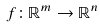Convert formula to latex. <formula><loc_0><loc_0><loc_500><loc_500>f \colon \mathbb { R } ^ { m } \to \mathbb { R } ^ { n }</formula> 